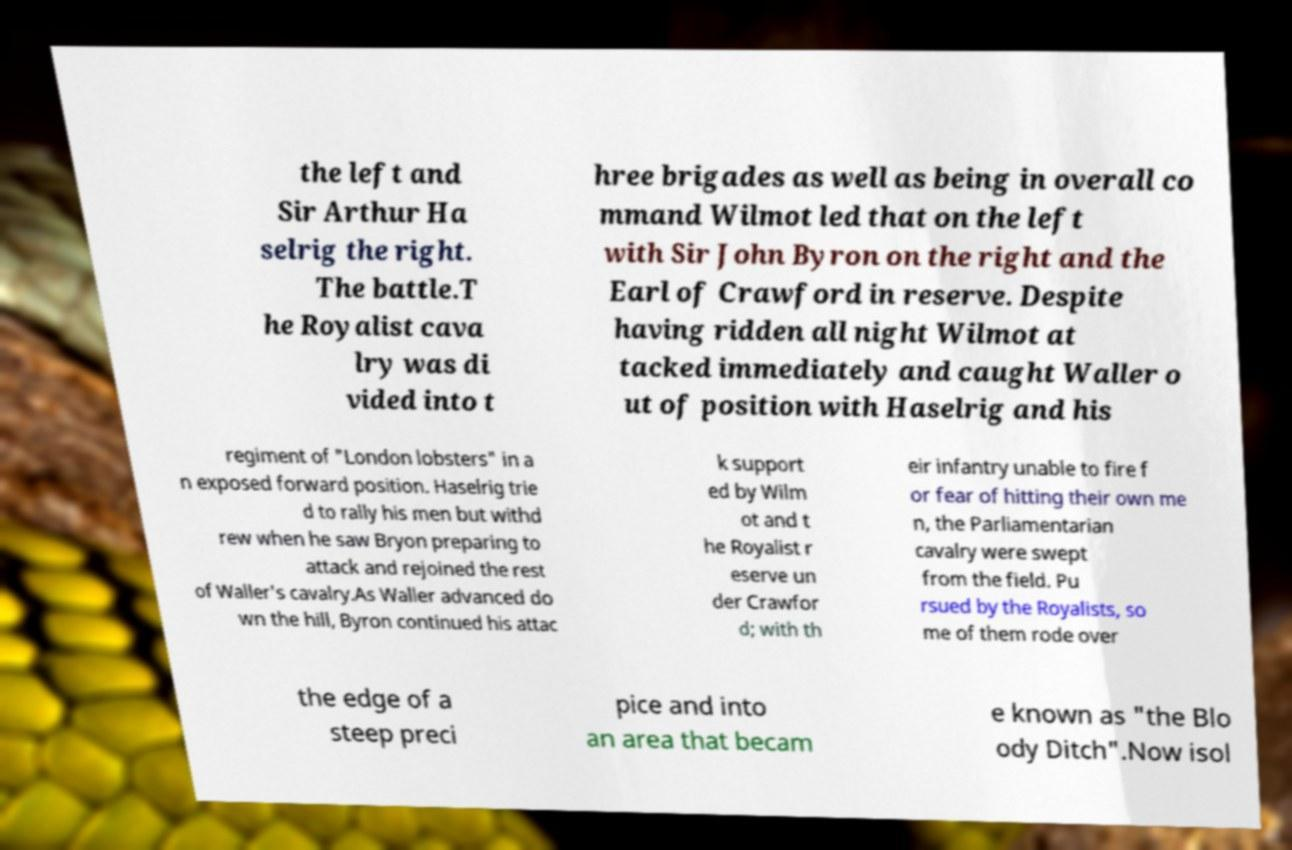There's text embedded in this image that I need extracted. Can you transcribe it verbatim? the left and Sir Arthur Ha selrig the right. The battle.T he Royalist cava lry was di vided into t hree brigades as well as being in overall co mmand Wilmot led that on the left with Sir John Byron on the right and the Earl of Crawford in reserve. Despite having ridden all night Wilmot at tacked immediately and caught Waller o ut of position with Haselrig and his regiment of "London lobsters" in a n exposed forward position. Haselrig trie d to rally his men but withd rew when he saw Bryon preparing to attack and rejoined the rest of Waller's cavalry.As Waller advanced do wn the hill, Byron continued his attac k support ed by Wilm ot and t he Royalist r eserve un der Crawfor d; with th eir infantry unable to fire f or fear of hitting their own me n, the Parliamentarian cavalry were swept from the field. Pu rsued by the Royalists, so me of them rode over the edge of a steep preci pice and into an area that becam e known as "the Blo ody Ditch".Now isol 